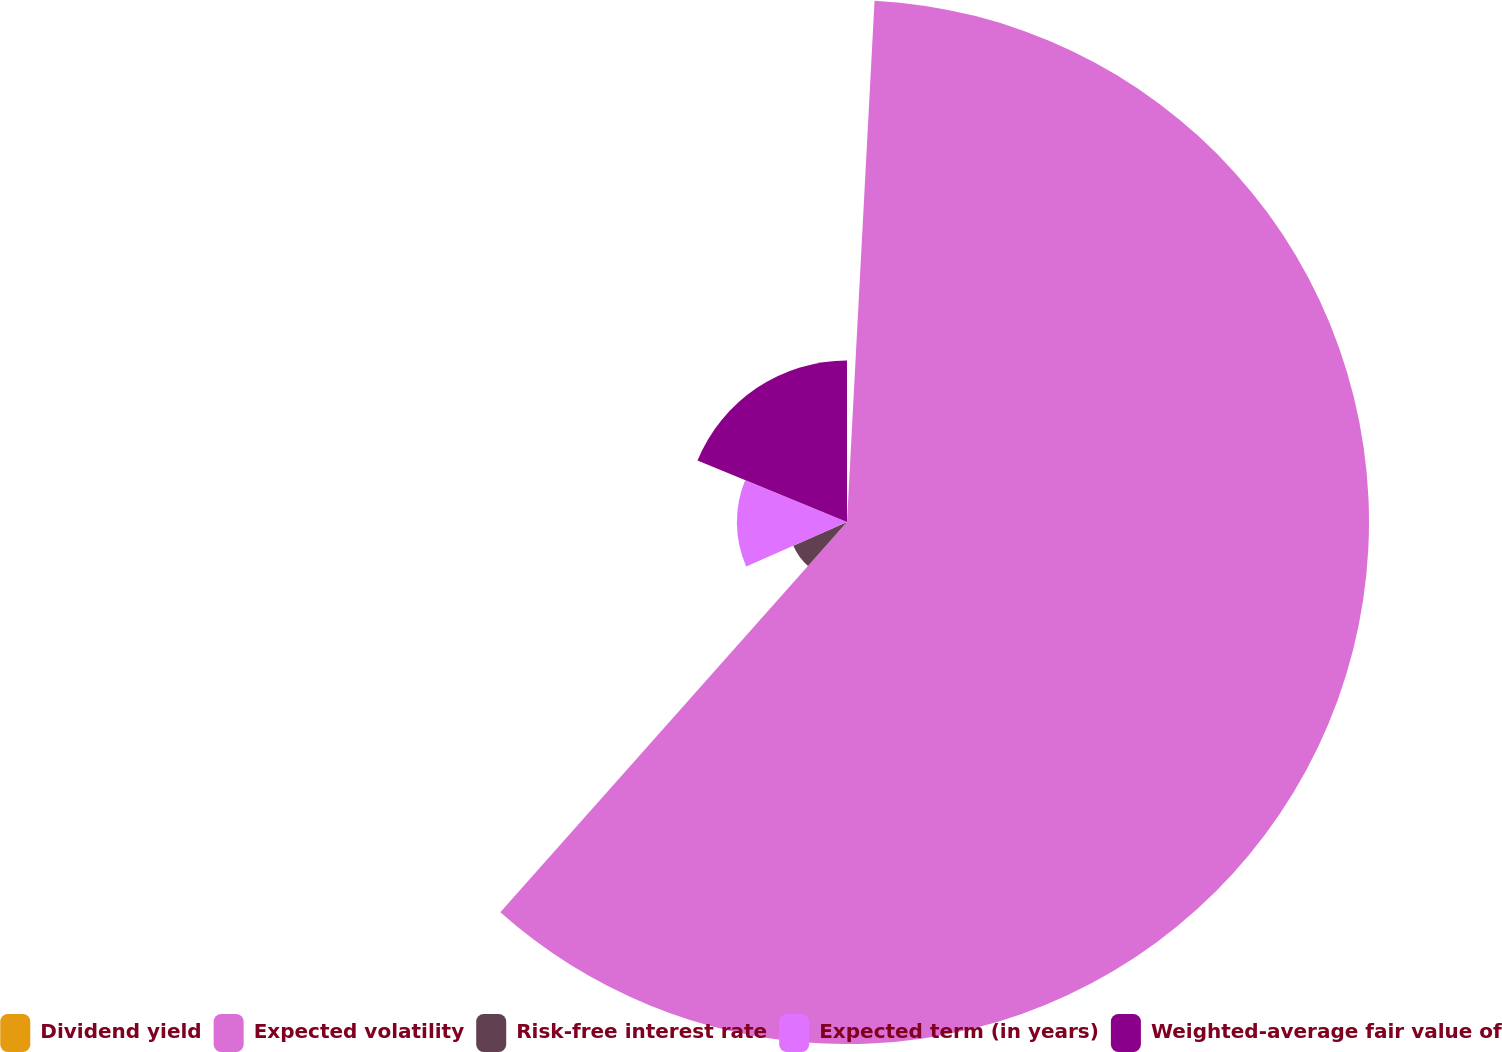Convert chart to OTSL. <chart><loc_0><loc_0><loc_500><loc_500><pie_chart><fcel>Dividend yield<fcel>Expected volatility<fcel>Risk-free interest rate<fcel>Expected term (in years)<fcel>Weighted-average fair value of<nl><fcel>0.84%<fcel>60.72%<fcel>6.83%<fcel>12.81%<fcel>18.8%<nl></chart> 